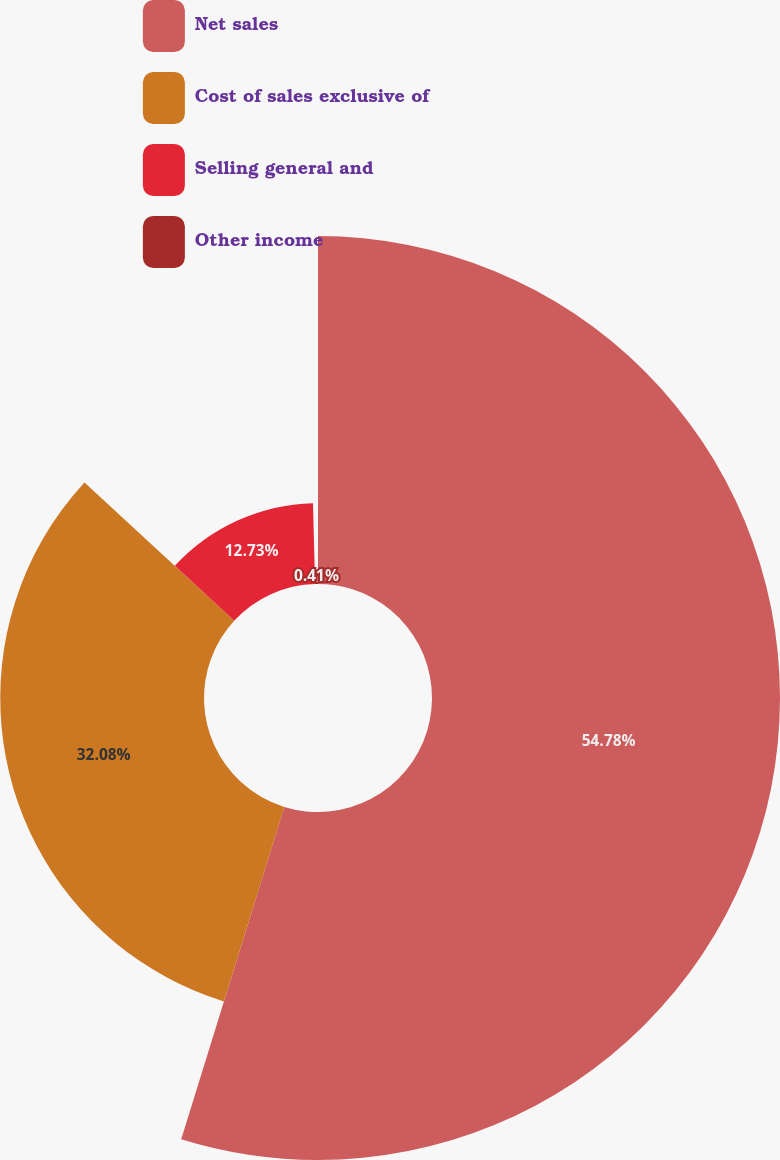Convert chart. <chart><loc_0><loc_0><loc_500><loc_500><pie_chart><fcel>Net sales<fcel>Cost of sales exclusive of<fcel>Selling general and<fcel>Other income<nl><fcel>54.79%<fcel>32.08%<fcel>12.73%<fcel>0.41%<nl></chart> 